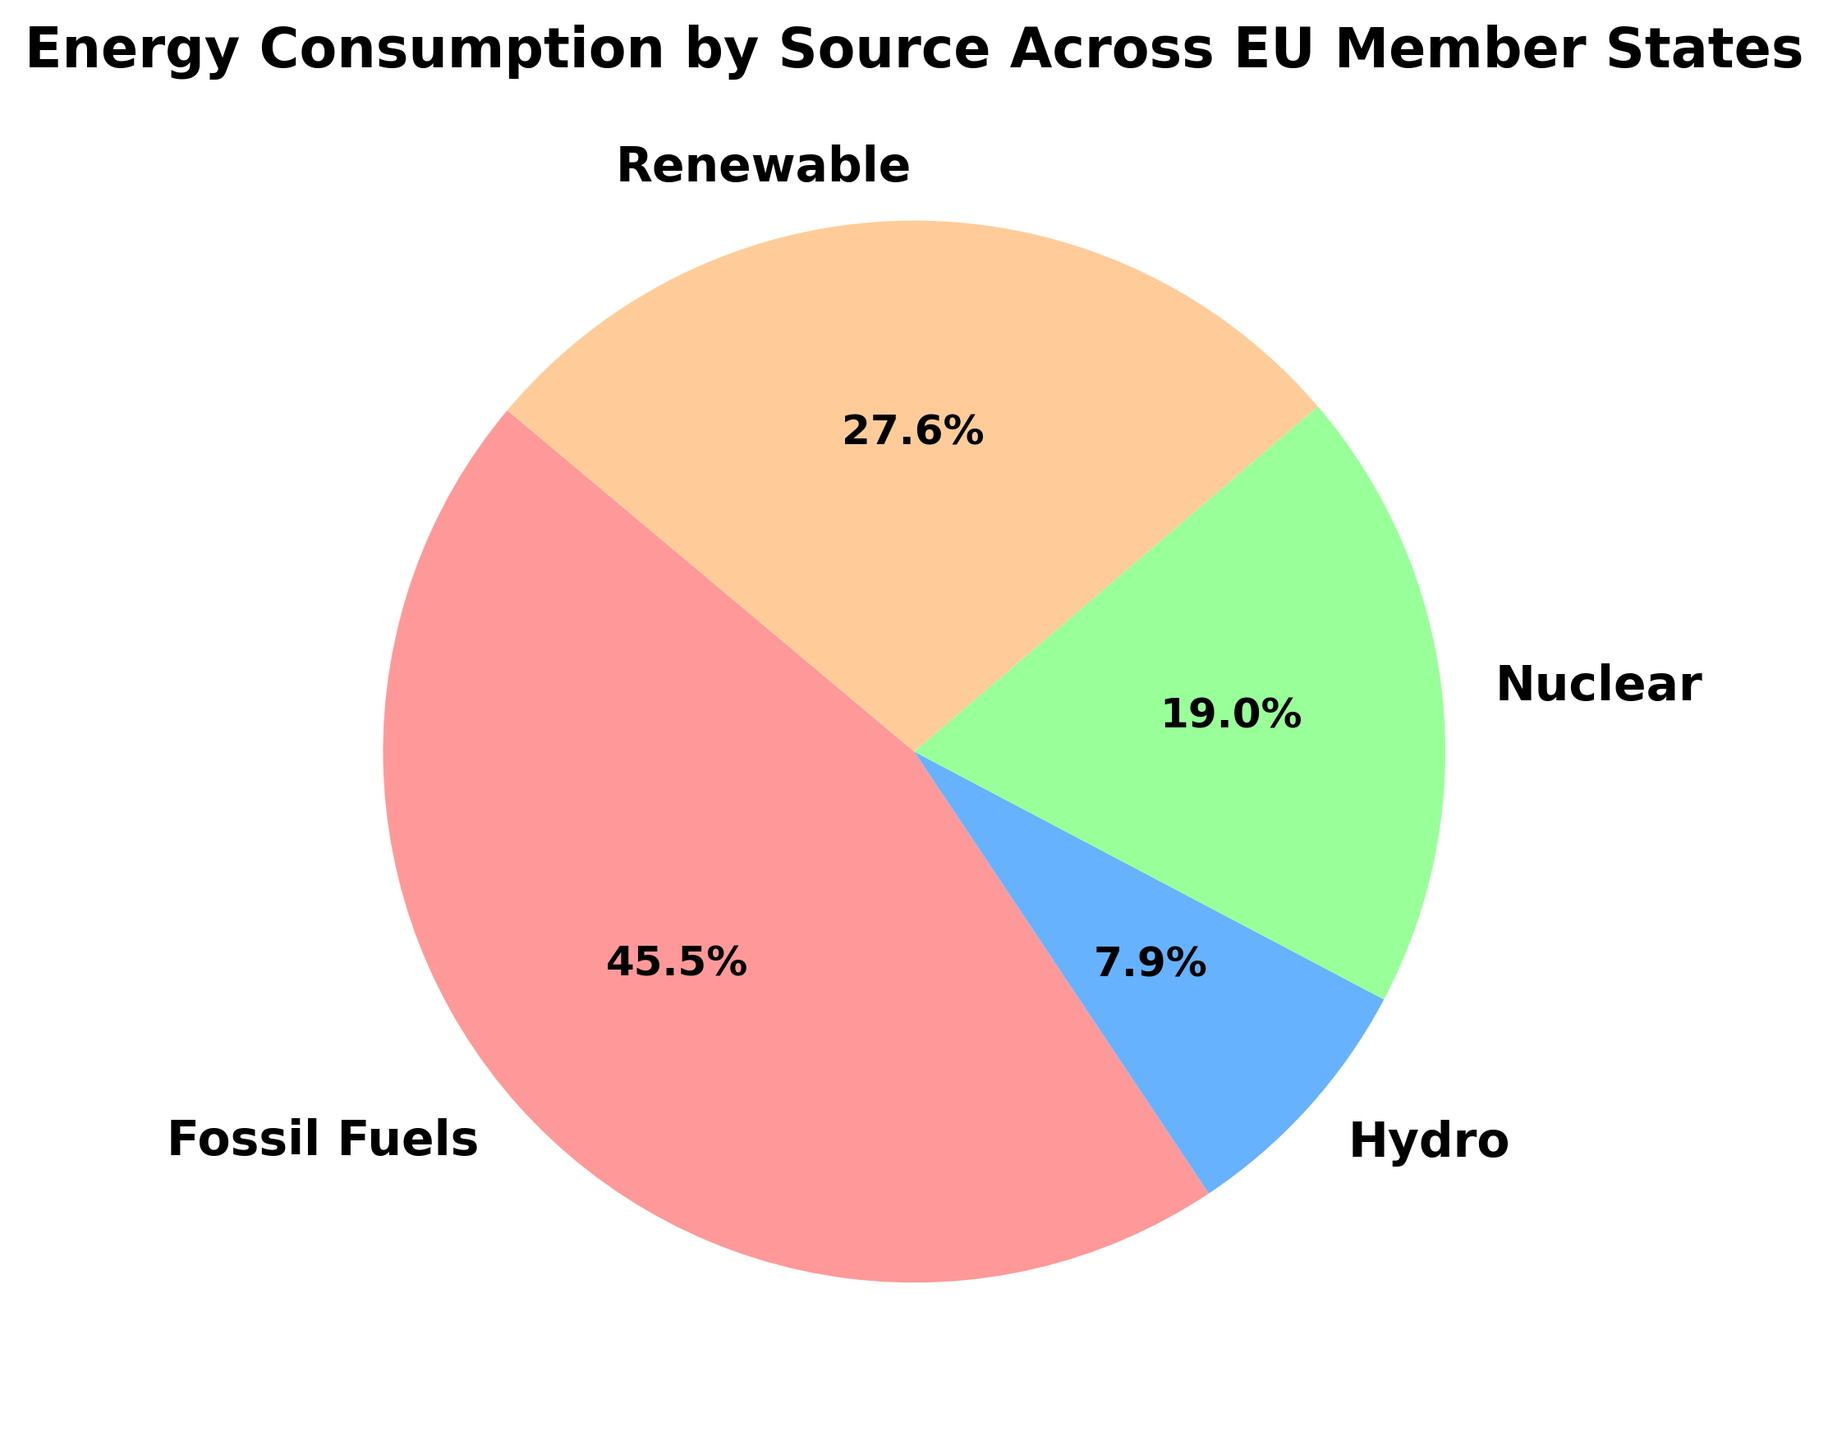What percentage of total energy consumption comes from renewables across the EU Member States? First, look at the percentage of the pie chart section that represents renewables. The label indicates the percentage directly.
Answer: 23.0% What is the second most significant source of energy consumption in the EU Member States? By visually inspecting the pie chart, identify the second largest pie section after fossil fuels. The label indicates the source as nuclear energy.
Answer: Nuclear How much more energy is consumed from fossil fuels compared to renewables across the EU? Determine the percentage values of fossil fuels and renewables from the pie chart. Subtract the renewable percentage from the fossil fuels percentage to find the difference.
Answer: 32.3% What is the color associated with hydro energy consumption in the pie chart? Identify the pie section labeled "Hydro" and note its color.
Answer: Orange Which energy source has the smallest share of total energy consumption in the EU? Look at the pie chart section that is smallest in size. The label will indicate the energy source.
Answer: Hydro 